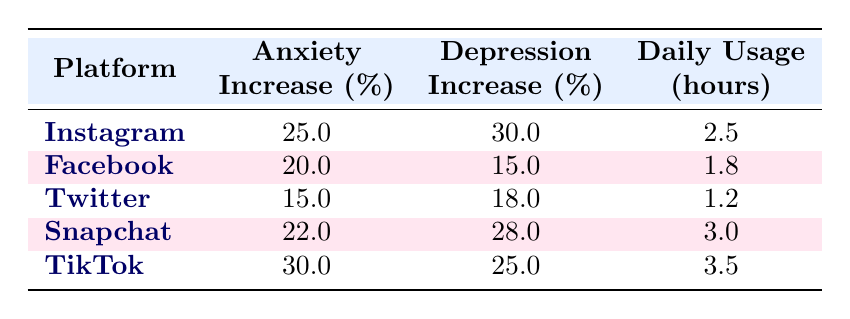What is the percentage increase in anxiety for TikTok users? The table lists the percentage increase in anxiety specifically for TikTok, showing it to be 30%.
Answer: 30% Which social media platform has the highest increase in depression? By comparing the percentage increase in depression across all platforms, TikTok has the highest percentage at 25%.
Answer: TikTok What is the average daily usage in hours across all platforms? To find the average, sum the daily usage hours: (2.5 + 1.8 + 1.2 + 3.0 + 3.5) = 12.0 hours, then divide by the number of platforms (5): 12.0 / 5 = 2.4 hours.
Answer: 2.4 Is the percentage increase in depression for Facebook less than 20%? The table shows that Facebook's percentage increase in depression is 15%, which is indeed less than 20%.
Answer: Yes Which platform shows a higher percentage increase in anxiety: Snapchat or Twitter? Snapchat has a percentage increase in anxiety of 22%, while Twitter has 15%. Since 22% is greater than 15%, Snapchat has a higher increase.
Answer: Snapchat 